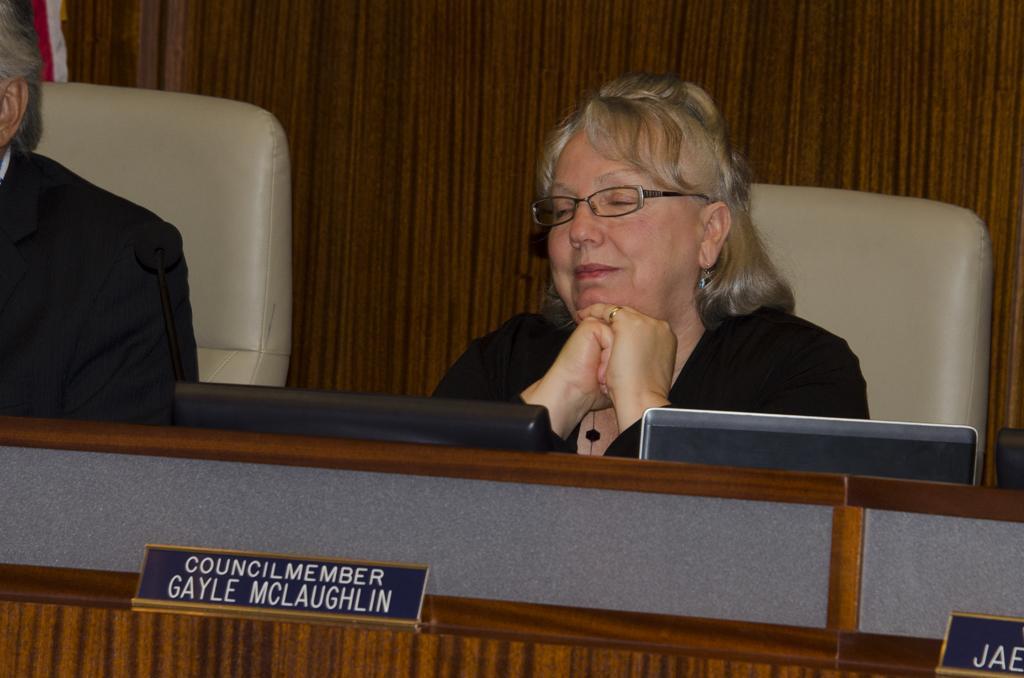Could you give a brief overview of what you see in this image? In this picture, we see two people are sitting on the chairs. The woman in the black dress is wearing the spectacles and she is smiling. In front of her, we see a table on which laptops are placed. We even see name boards are placed on the table. This table is in brown color. In the background, we see the brown wall or a cupboard. 